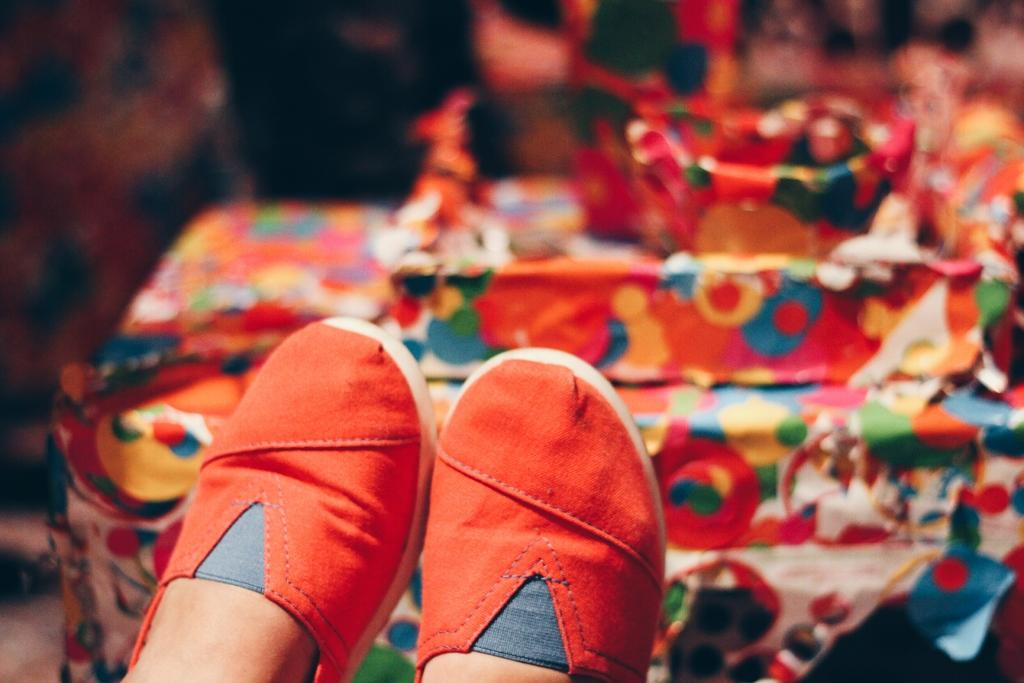What objects are in the foreground of the image? There are two shoes in the foreground of the image. What part of a person's body do the shoes belong to? The shoes are associated with a person's legs. What can be seen in the background of the image? There is a table in the background of the image. What is on the table in the background? There are objects on the table in the background. What type of ground is visible beneath the shoes in the image? There is no ground visible in the image; it only shows the shoes and a table in the background. 